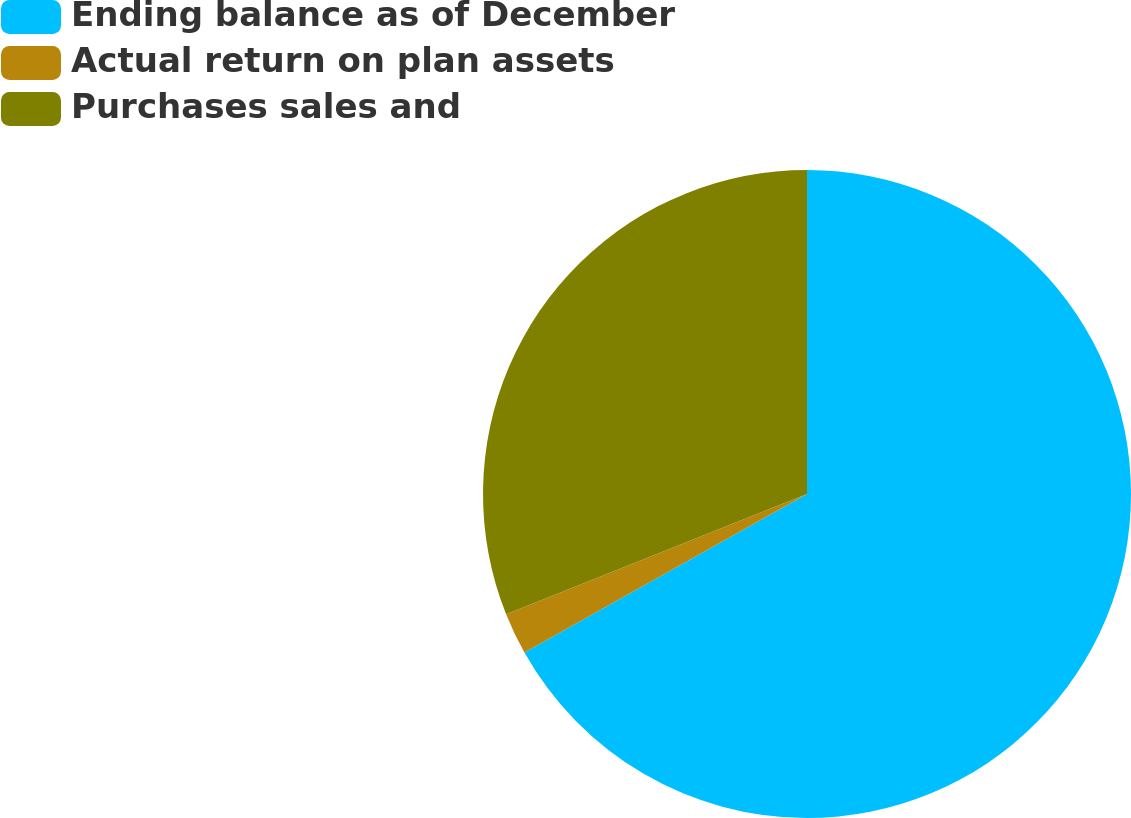<chart> <loc_0><loc_0><loc_500><loc_500><pie_chart><fcel>Ending balance as of December<fcel>Actual return on plan assets<fcel>Purchases sales and<nl><fcel>66.86%<fcel>2.09%<fcel>31.05%<nl></chart> 